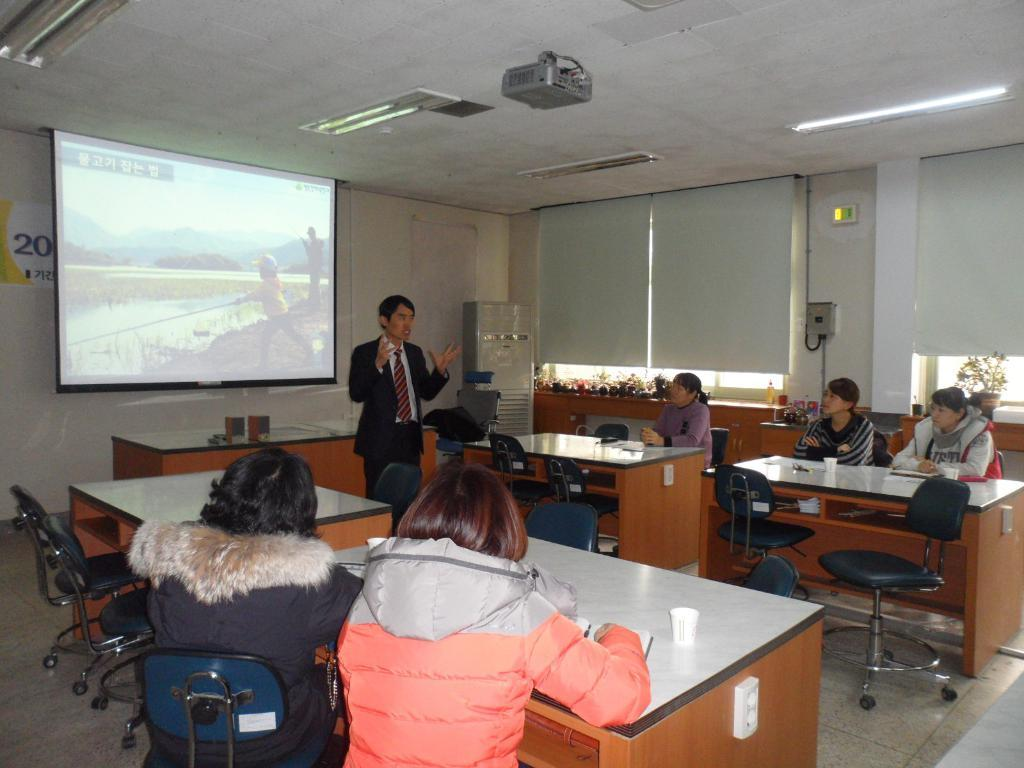What are the people in the room doing? The people in the room are sitting on chairs. What furniture is present in the room besides the chairs? There is a table in the room. What can be found on the table? There are cups on the table. Is there anyone standing in the room? Yes, there is a person standing in the room. What type of equipment is in the room? There is a screen projector in the room. What type of bait is being used to catch fish in the room? There is no mention of fish or bait in the image; the room contains people, chairs, a table, cups, a standing person, and a screen projector. 